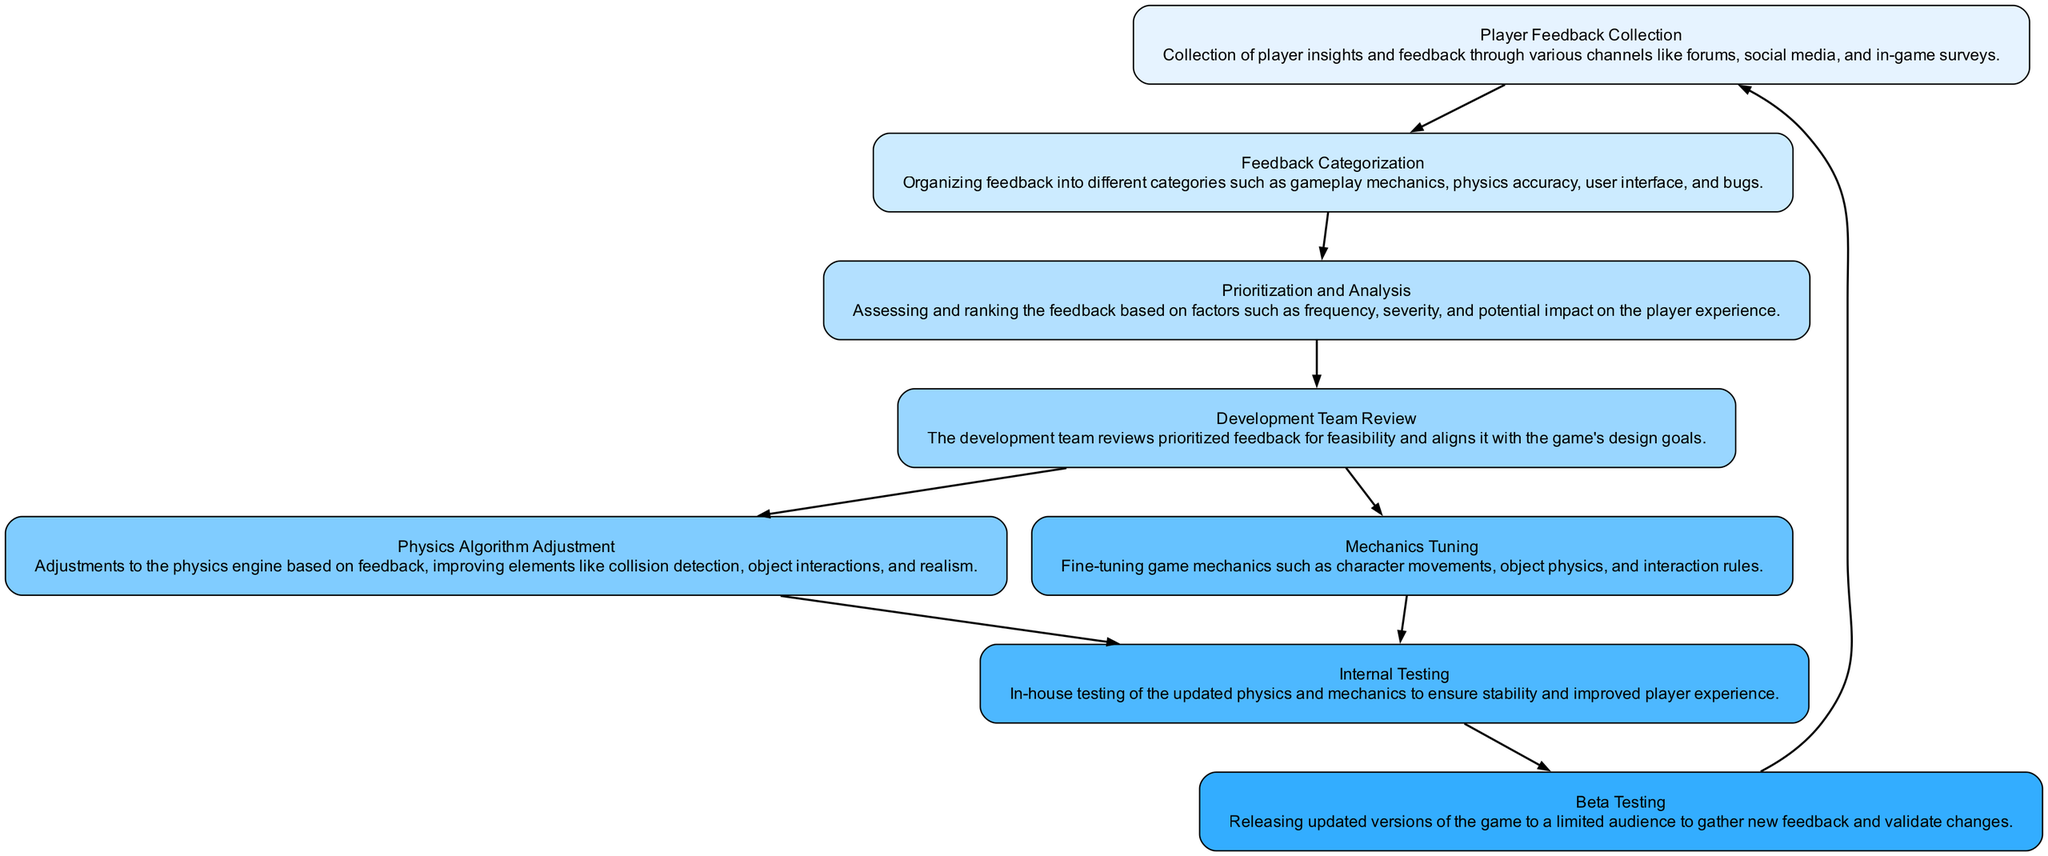What is the first step in the feedback integration process? The first element in the diagram represents "Player Feedback Collection," indicating that the process starts with gathering player feedback through various channels.
Answer: Player Feedback Collection How many connections does the "Internal Testing" node have? From the diagram, the "Internal Testing" node has two connections leading to "Beta Testing," which indicates that it connects the tested updates to the next stage in the process.
Answer: 2 What directly follows "Development Team Review"? The diagram shows that "Development Team Review" connects directly to both "Physics Algorithm Adjustment" and "Mechanics Tuning," indicating these actions occur subsequently.
Answer: Physics Algorithm Adjustment, Mechanics Tuning Which node involves categorizing player feedback? The node that deals with organizing feedback into various categories after it has been collected is "Feedback Categorization." This node groups feedback based on different aspects of the game.
Answer: Feedback Categorization Identify the node that takes player insights and implements changes to the game's physics. The node responsible for adjusting elements in the physics engine based on player feedback is "Physics Algorithm Adjustment," which focuses specifically on the physics aspect as per player insights.
Answer: Physics Algorithm Adjustment What is the main purpose of "Beta Testing"? The primary function of "Beta Testing" is to release updated versions of the game to a limited audience for feedback on the changes made, validating the alterations before a wider release.
Answer: Gather new feedback Which nodes connect to "Mechanics Tuning"? "Mechanics Tuning" connects to "Development Team Review" as the previous step in the process and to "Internal Testing" as the next stage, indicating its position in the feedback integration flow.
Answer: Development Team Review, Internal Testing What happens after player feedback is categorized? After feedback is categorized under "Feedback Categorization," it moves to "Prioritization and Analysis," where it is assessed and ranked based on certain criteria affecting gameplay.
Answer: Prioritization and Analysis What kind of feedback is collected in the first step? The first step focuses on collecting player insights and feedback through various channels, including forums, social media, and in-game surveys, related to the overall gaming experience.
Answer: Player insights and feedback 